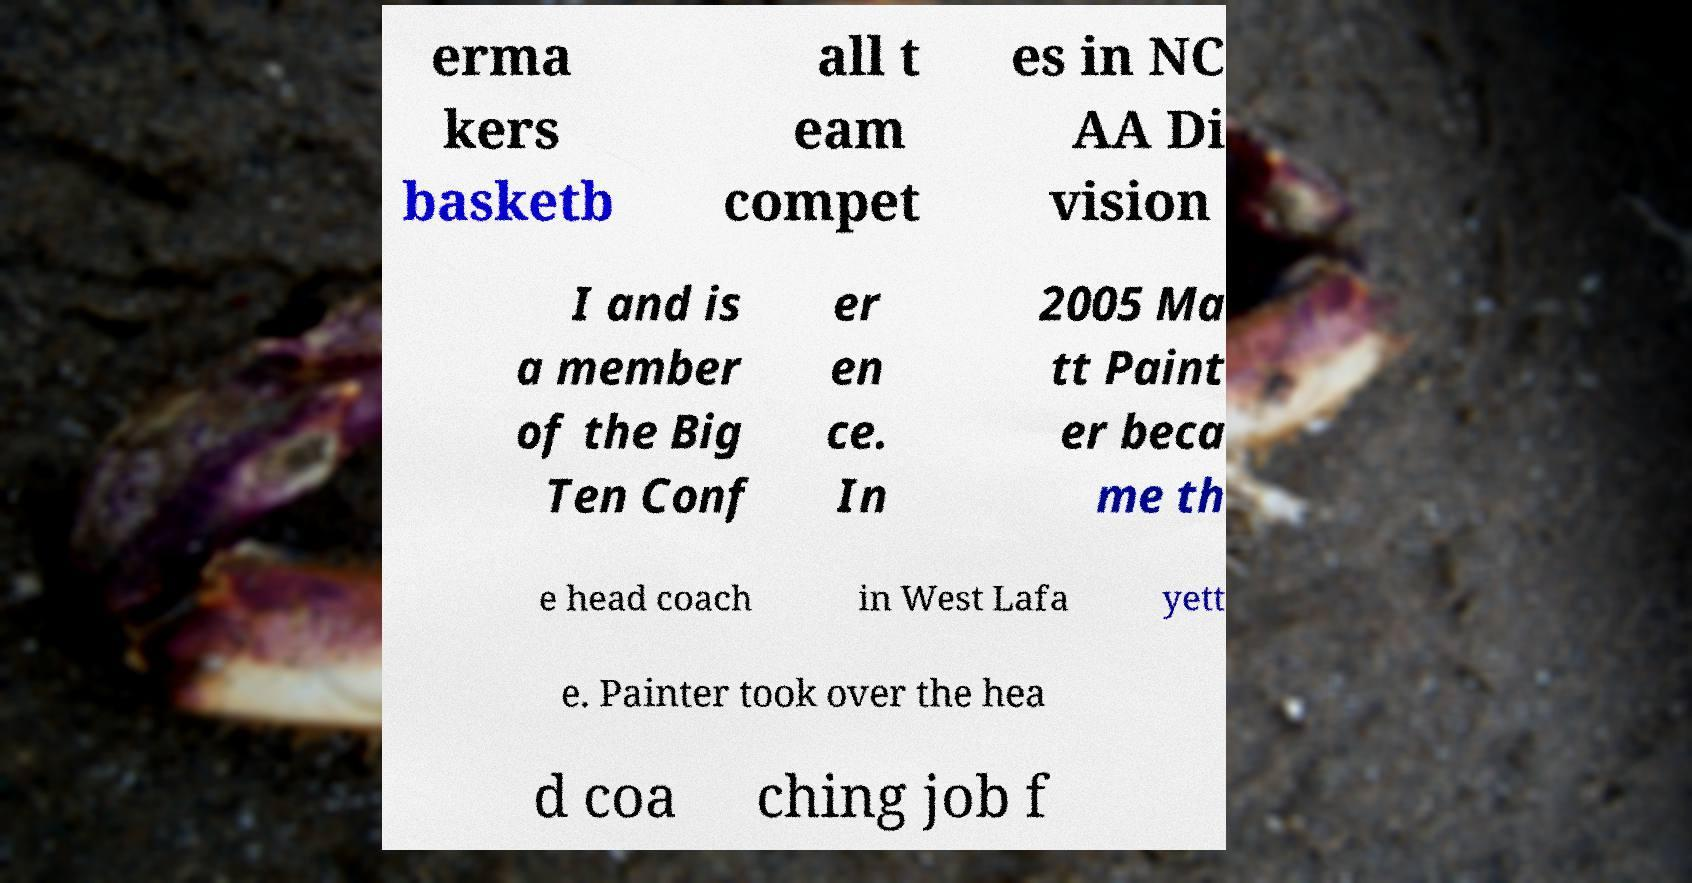Please read and relay the text visible in this image. What does it say? erma kers basketb all t eam compet es in NC AA Di vision I and is a member of the Big Ten Conf er en ce. In 2005 Ma tt Paint er beca me th e head coach in West Lafa yett e. Painter took over the hea d coa ching job f 